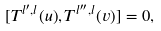Convert formula to latex. <formula><loc_0><loc_0><loc_500><loc_500>[ T ^ { l ^ { \prime } , l } ( u ) , T ^ { l ^ { \prime \prime } , l } ( v ) ] = 0 ,</formula> 